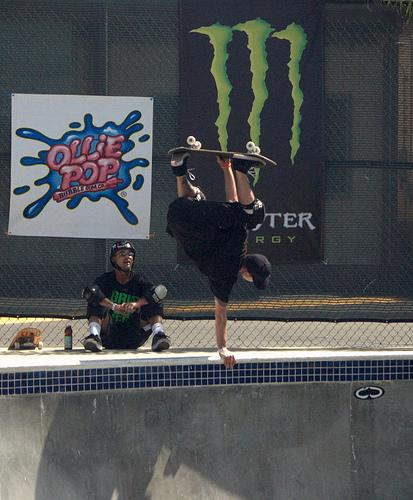What is the narcotic made popular by the poster on the wall?

Choices:
A) marijuana
B) caffeine
C) cocaine
D) meth caffeine 